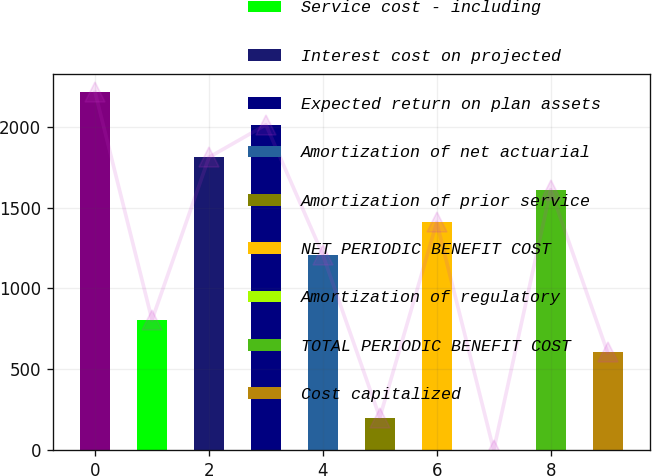Convert chart. <chart><loc_0><loc_0><loc_500><loc_500><bar_chart><fcel>(Millions of Dollars)<fcel>Service cost - including<fcel>Interest cost on projected<fcel>Expected return on plan assets<fcel>Amortization of net actuarial<fcel>Amortization of prior service<fcel>NET PERIODIC BENEFIT COST<fcel>Amortization of regulatory<fcel>TOTAL PERIODIC BENEFIT COST<fcel>Cost capitalized<nl><fcel>2211.9<fcel>805.6<fcel>1810.1<fcel>2011<fcel>1207.4<fcel>202.9<fcel>1408.3<fcel>2<fcel>1609.2<fcel>604.7<nl></chart> 